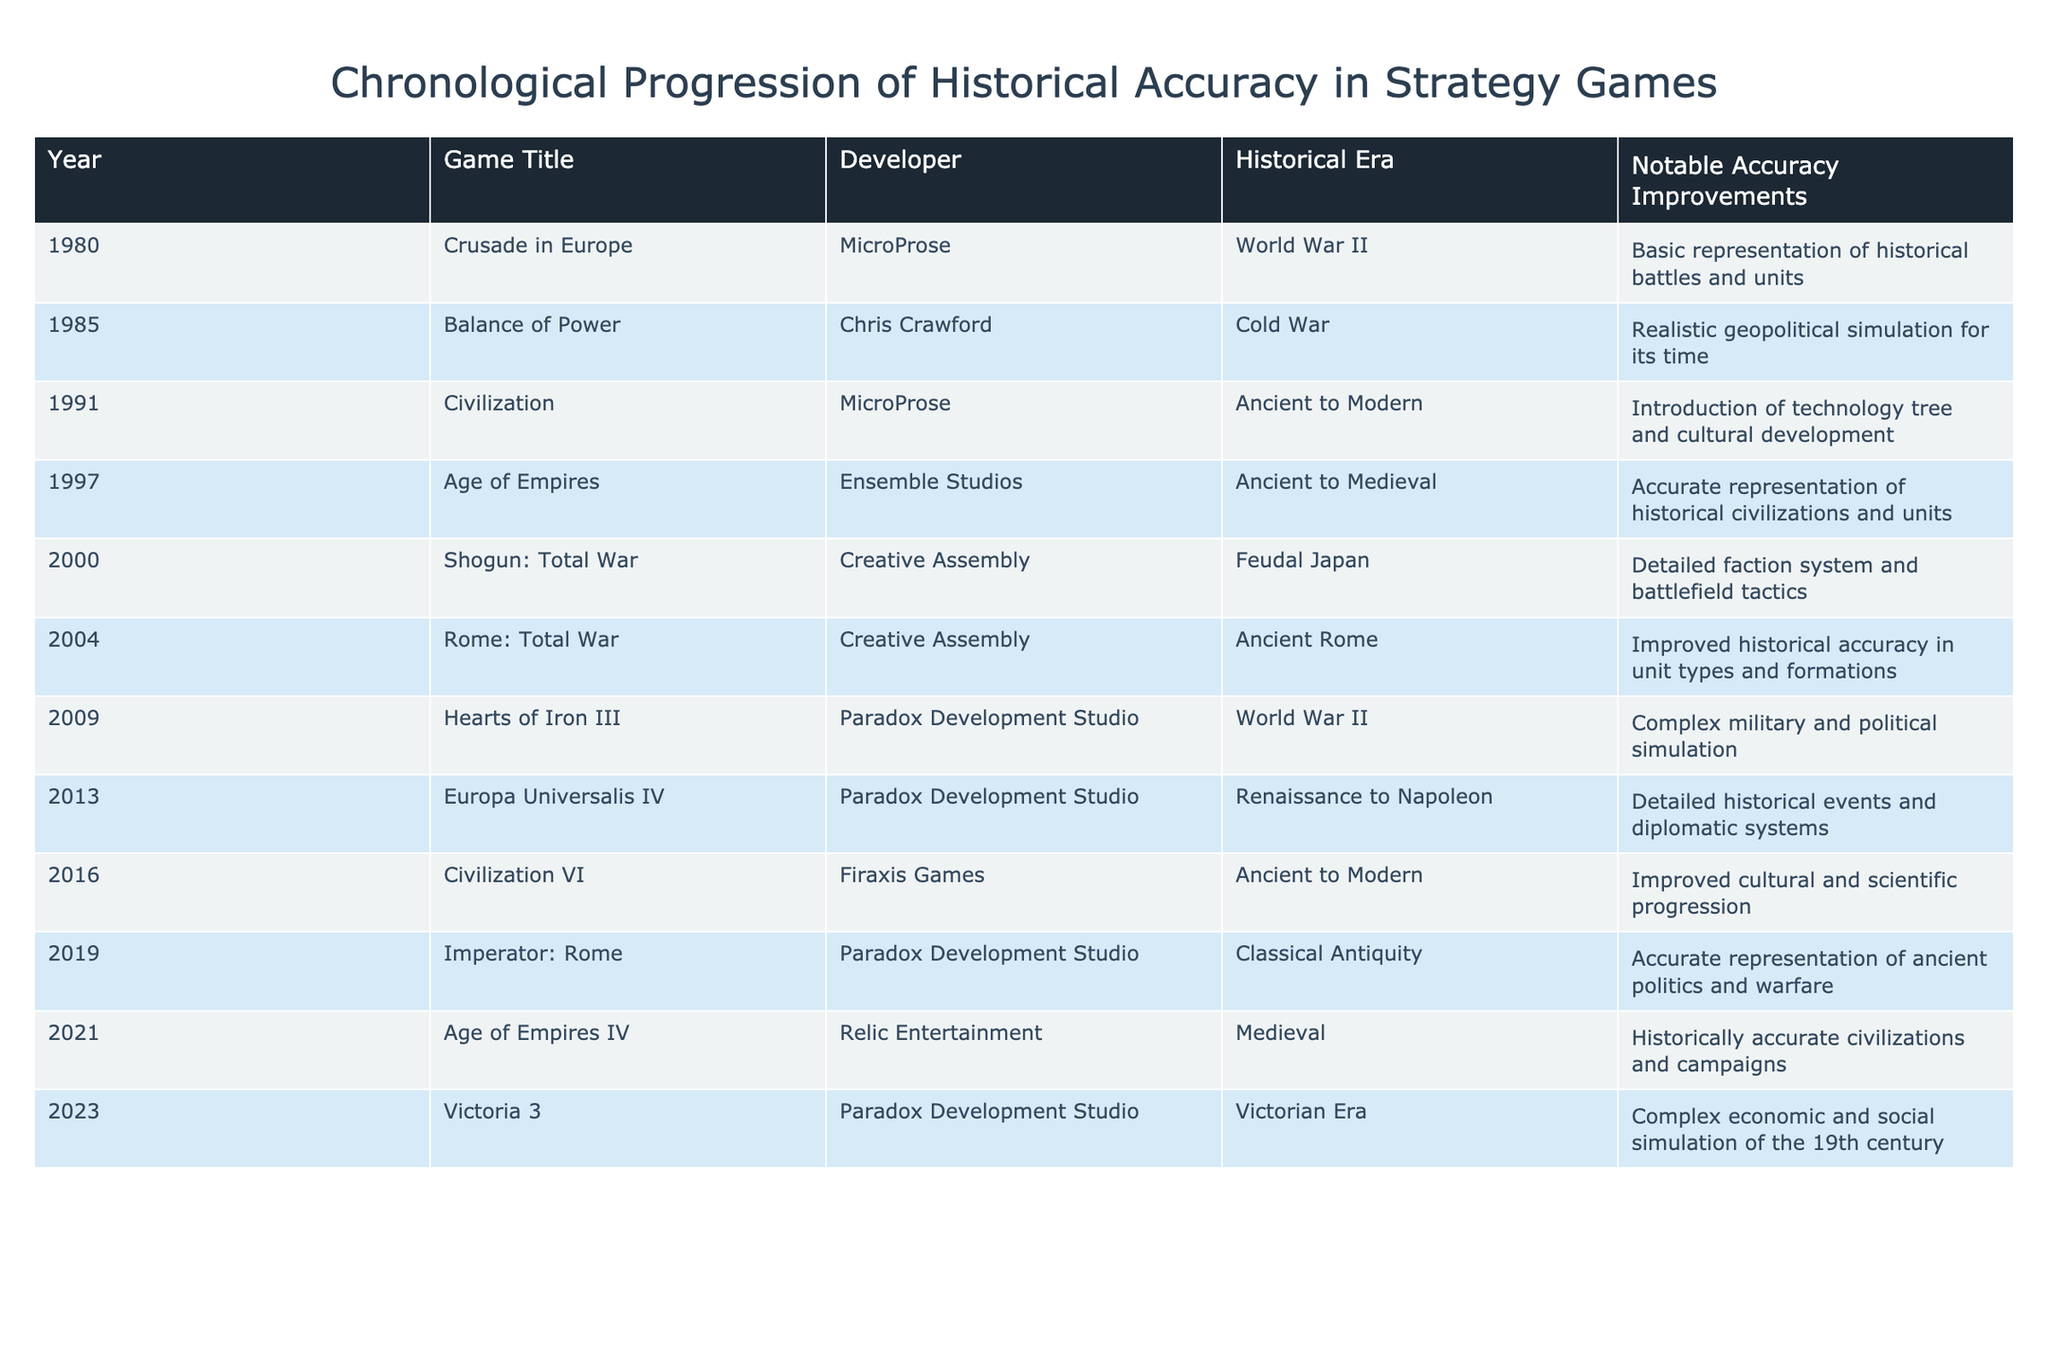What is the historical era of "Civilization VI"? "Civilization VI" was released in 2016, and it is categorized under the "Ancient to Modern" historical era according to the table.
Answer: Ancient to Modern Which game developed by Paradox Development Studio focuses on the Renaissance to Napoleon period? The table shows that "Europa Universalis IV," released in 2013, was developed by Paradox Development Studio and is focused on the Renaissance to Napoleon period.
Answer: Europa Universalis IV How many games were released between 2000 and 2010? The games released between 2000 and 2010 include "Shogun: Total War" (2000), "Rome: Total War" (2004), and "Hearts of Iron III" (2009). Counting these gives us a total of 3 games.
Answer: 3 True or false: "Age of Empires IV" was released in the Victorian Era. According to the table, "Age of Empires IV" was released in 2021, and its historical era is categorized as Medieval, which makes the statement false.
Answer: False What notable accuracy improvement was introduced in "Age of Empires"? The table states that "Age of Empires," released in 1997, had an accurate representation of historical civilizations and units as its notable accuracy improvement.
Answer: Accurate representation of historical civilizations and units What was the first game listed in the table that improved historical accuracy in unit types and formations, and what year was it released? Referring to the table, "Rome: Total War" is the first game listed that improved historical accuracy in unit types and formations, and it was released in 2004.
Answer: Rome: Total War, 2004 Which game has the most recent notable accuracy improvement according to the table? The most recent game in the table is "Victoria 3," released in 2023, with the notable accuracy improvement being a complex economic and social simulation of the 19th century.
Answer: Victoria 3 Determine the number of games listed that are based on World War II. The table lists "Crusade in Europe" (1980) and "Hearts of Iron III" (2009) as games based on World War II. Thus, the total number of such games is 2.
Answer: 2 Identify the game with the earliest release date that features a realistic geopolitical simulation. The table shows that "Balance of Power" was developed by Chris Crawford and released in 1985, featuring a realistic geopolitical simulation for its time. Thus, this game has the earliest release date for such a feature.
Answer: Balance of Power 